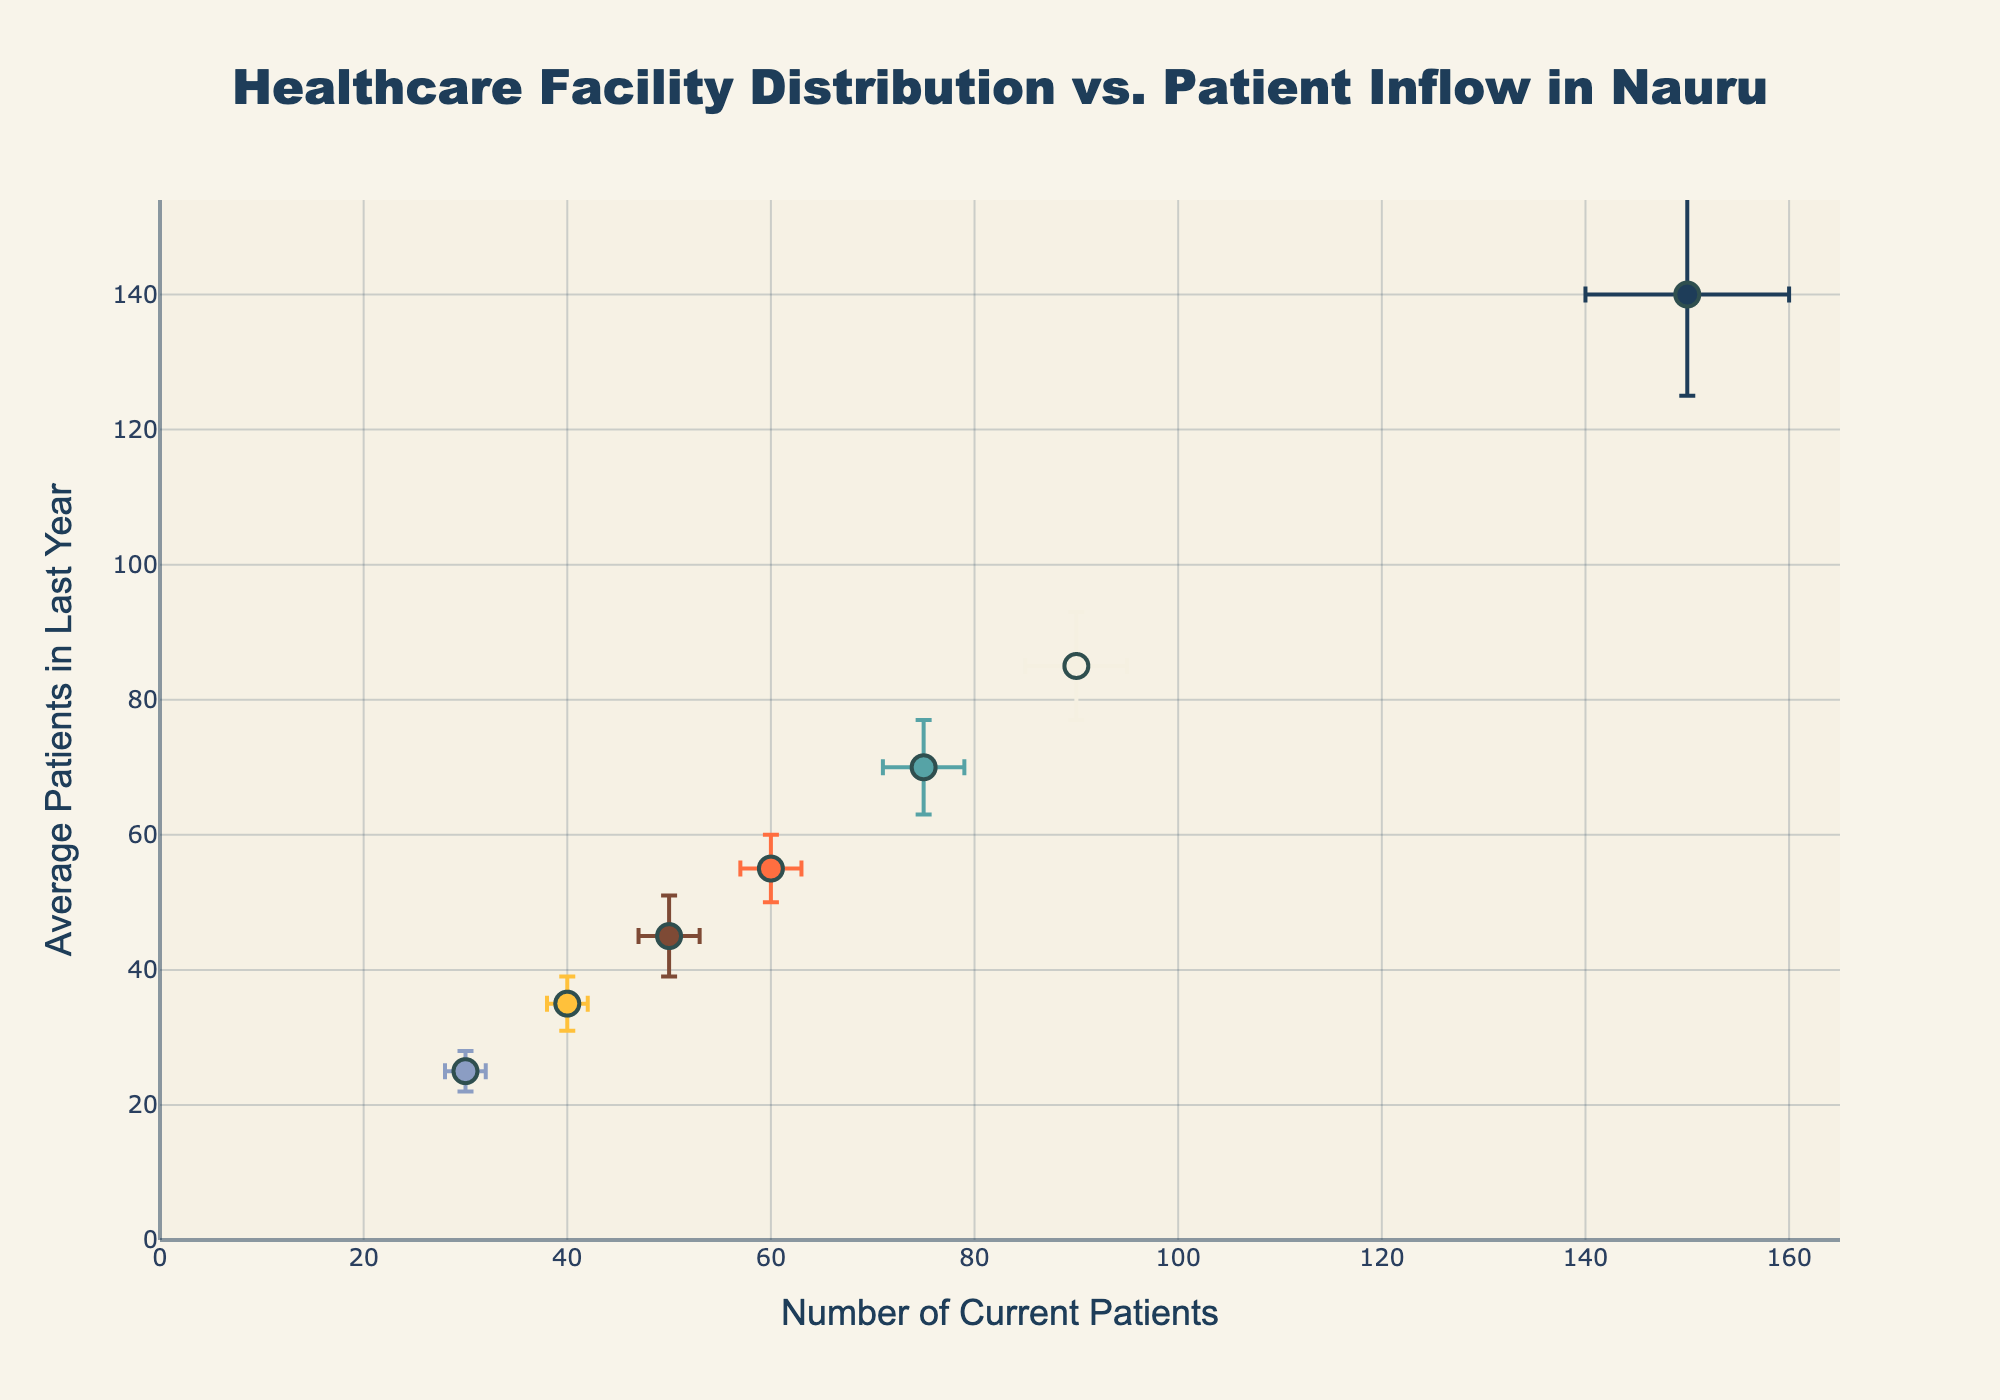What is the title of the scatter plot? The title of the figure is centered at the top and is highlighted at a larger font size.
Answer: Healthcare Facility Distribution vs. Patient Inflow in Nauru Which healthcare facility has the highest number of current patients? By looking at the x-axis, we see the data point furthest to the right, which corresponds to the healthcare facility with the highest number of current patients.
Answer: Nauru General Hospital How many healthcare facilities are represented in the scatter plot? Count the distinct data points labeled with different healthcare facilities.
Answer: 7 What is the average number of patients in the last year for Aiwo Health Center? Refer to the y-axis and locate the data point labeled "Aiwo Health Center"; find its y-coordinate.
Answer: 85 Which facility has the largest seasonal variation in current patient numbers? The facility with the longest error bar on the x-axis represents the highest seasonal variation.
Answer: Nauru General Hospital How does Nauru General Hospital compare to Aiwo Health Center in terms of average patients in the last year? Compare the y-values of the data points for both Nauru General Hospital and Aiwo Health Center.
Answer: Nauru General Hospital has higher average patients in the last year What is the difference in the number of current patients between the Nauru General Hospital and Uaboe Dispensary? Subtract the x-value for Uaboe Dispensary from the x-value for Nauru General Hospital.
Answer: 120 Which facility shows the smallest standard deviation in patient numbers over the last year? The facility with the smallest error bar on the y-axis has the smallest standard deviation.
Answer: Uaboe Dispensary How does the patient inflow to Baiti Clinic vary seasonally? Look at the error bar length on the x-axis for Baiti Clinic to interpret the seasonal variation.
Answer: +/- 3 Are there any facilities where the number of current patients is lower than the average number of patients in the last year? If yes, name one. Compare the x-axis and y-axis values for each facility. If the x-value is less than the y-value, it indicates current patients are fewer than average in the last year.
Answer: Uaboe Dispensary 